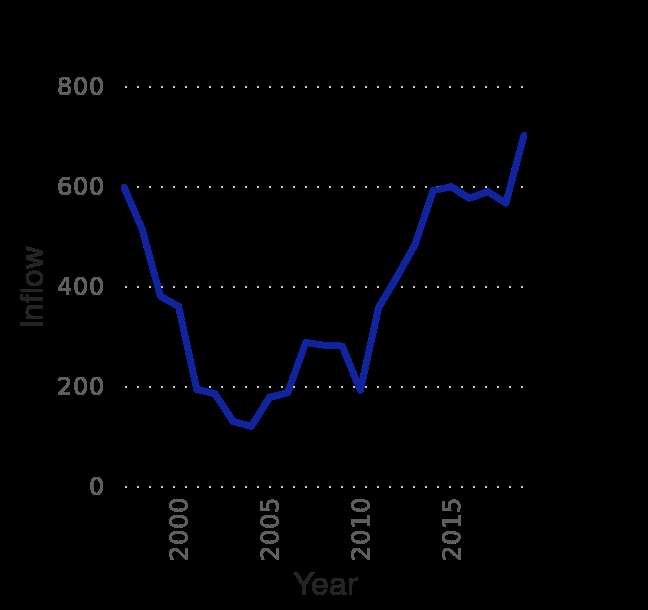<image>
What does the x-axis represent? The x-axis represents the years from 1997 to 2019. How does migration in 2017/2018 compare to previous years? Migration in 2017/2018 exceeded its previous records. By how much did migration drop between 2003 and 2011? Migration dropped over 60% between 2003 and 2011. 